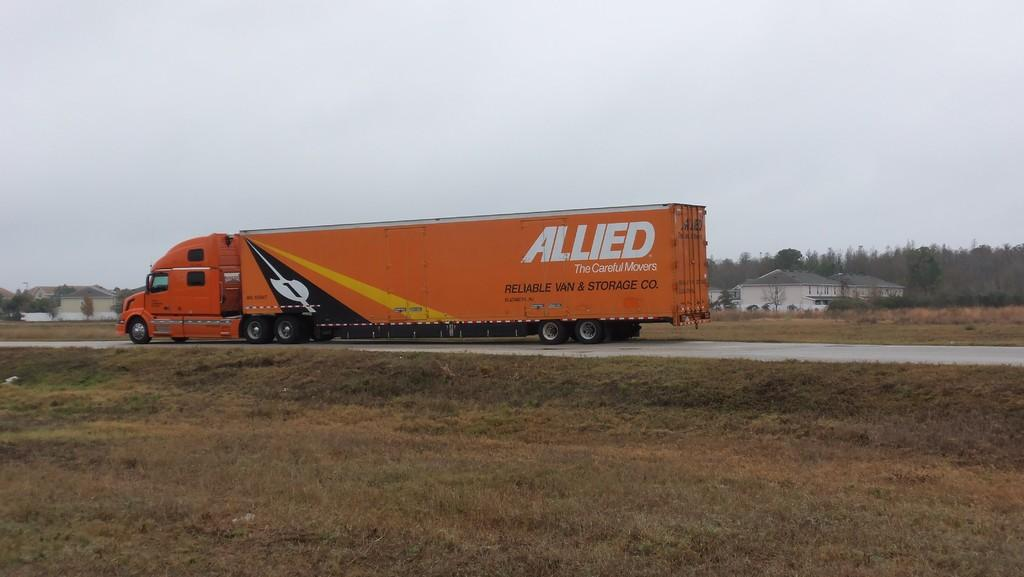What type of vehicle is in the image? There is a big truck in the image. What color is the truck? The truck is orange in color. What is the truck doing in the image? The truck is moving on the road. What can be seen on the right side of the image? There are houses on the right side of the image. How would you describe the sky in the image? The sky is cloudy in the image. Can you see the parent holding the thumb of the child in the image? There is no parent or child present in the image, and therefore no such interaction can be observed. 